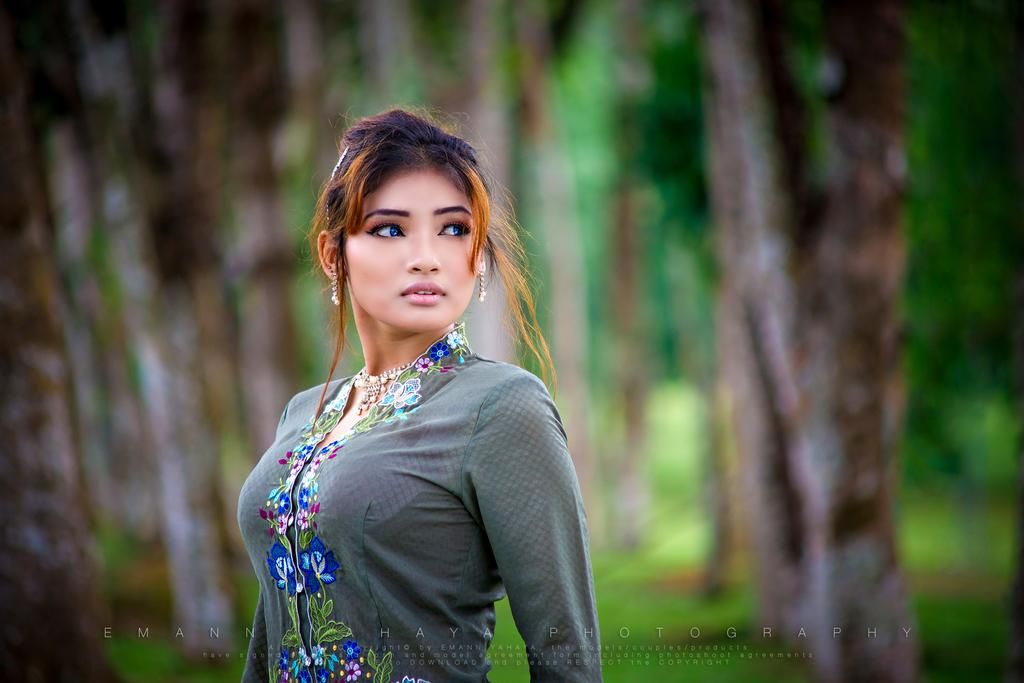Who is the main subject in the image? There is a girl in the image. What is the girl doing in the image? The girl is standing in the image. In which direction is the girl looking? The girl is looking to the right side of the image. Can you describe the background of the image? The background of the image is blurry. What is the price of the beef at the cemetery in the image? There is no mention of beef or a cemetery in the image; it features a girl standing and looking to the right side of the image. 